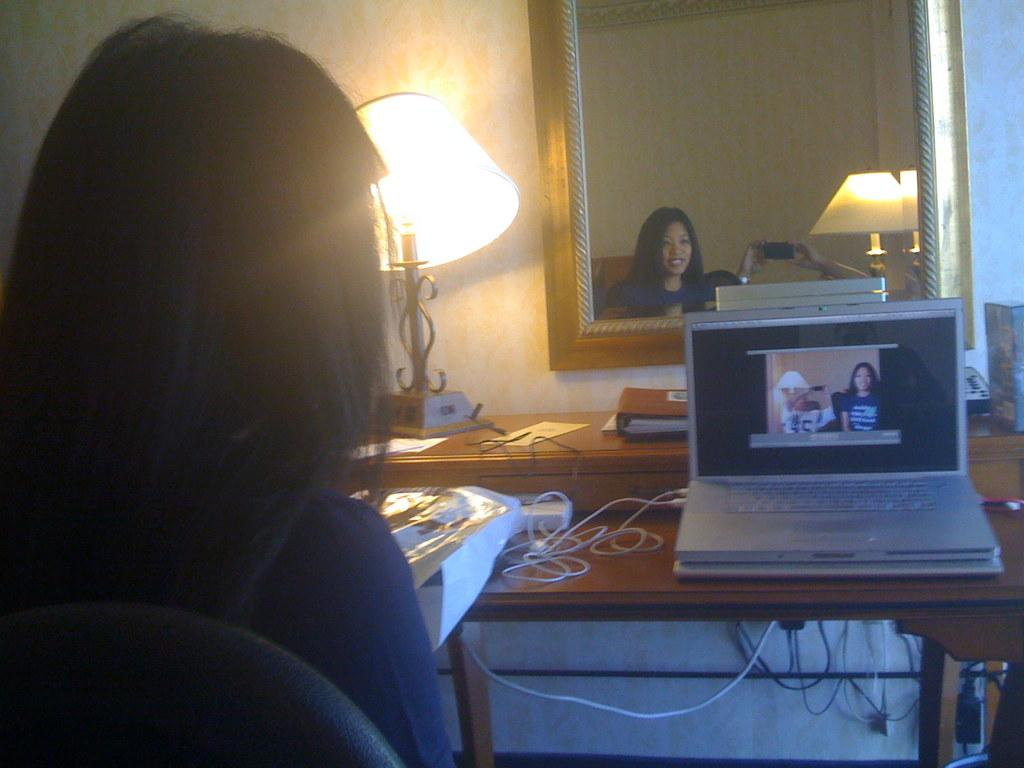Who is the main subject in the image? There is a woman in the image. What is the woman doing in the image? The woman is sitting on a chair and looking at a laptop. Where is the laptop located in the image? The laptop is on a table. Can you describe the woman's reflection in the image? The woman's face is visible in a mirror. What advice does the man give to the woman in the image? There is no man present in the image, so no advice can be given. 